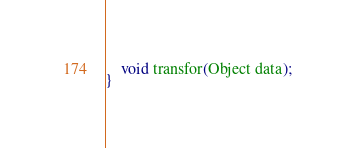Convert code to text. <code><loc_0><loc_0><loc_500><loc_500><_Java_>    void transfor(Object data);
}
</code> 